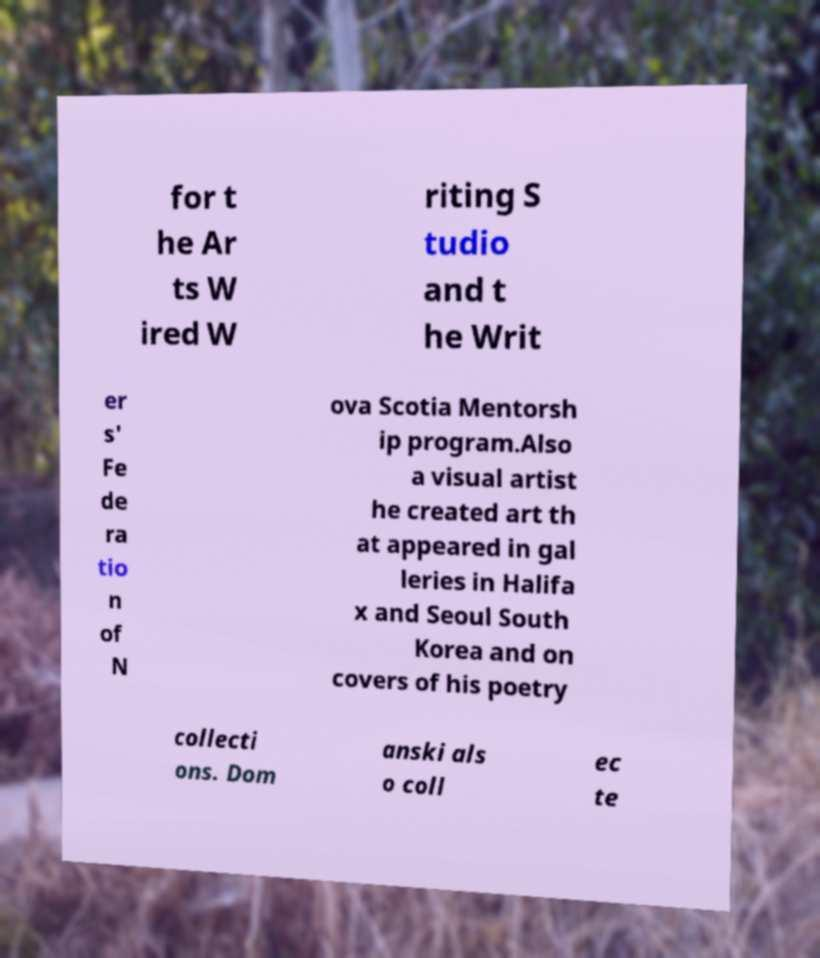Could you assist in decoding the text presented in this image and type it out clearly? for t he Ar ts W ired W riting S tudio and t he Writ er s' Fe de ra tio n of N ova Scotia Mentorsh ip program.Also a visual artist he created art th at appeared in gal leries in Halifa x and Seoul South Korea and on covers of his poetry collecti ons. Dom anski als o coll ec te 